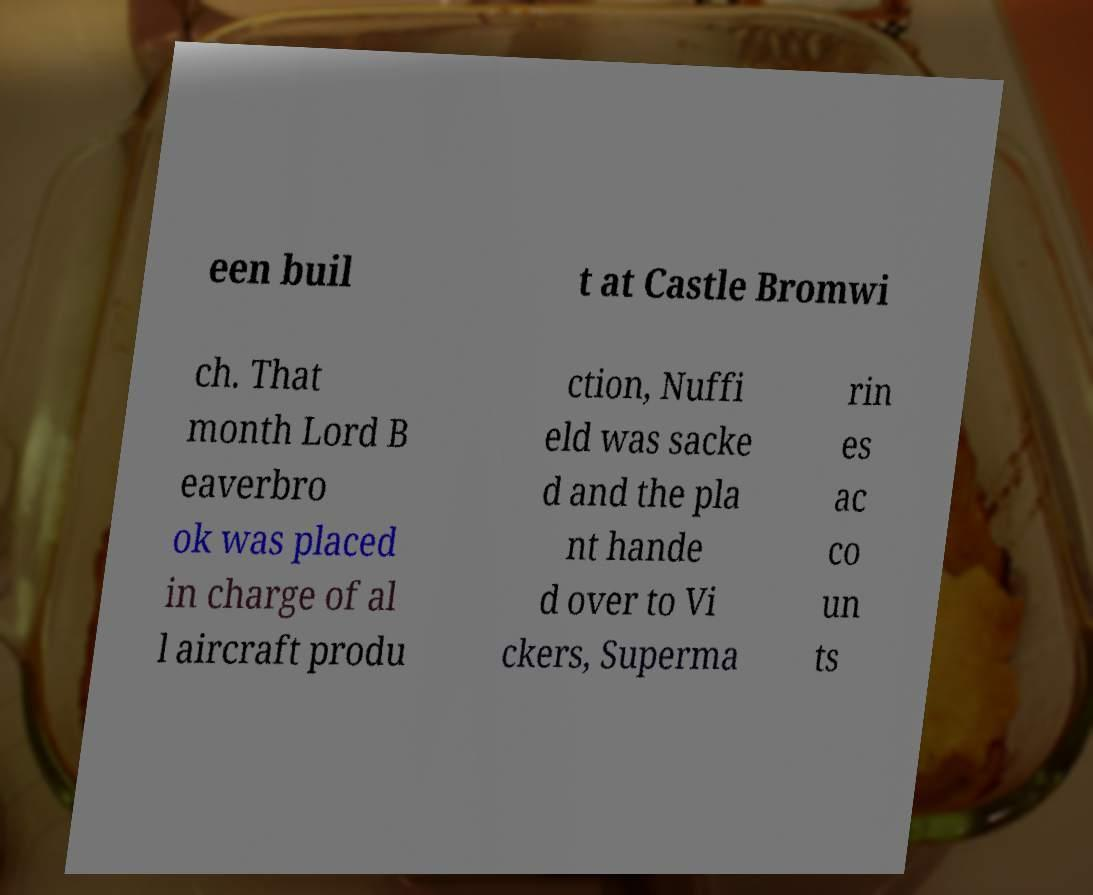For documentation purposes, I need the text within this image transcribed. Could you provide that? een buil t at Castle Bromwi ch. That month Lord B eaverbro ok was placed in charge of al l aircraft produ ction, Nuffi eld was sacke d and the pla nt hande d over to Vi ckers, Superma rin es ac co un ts 